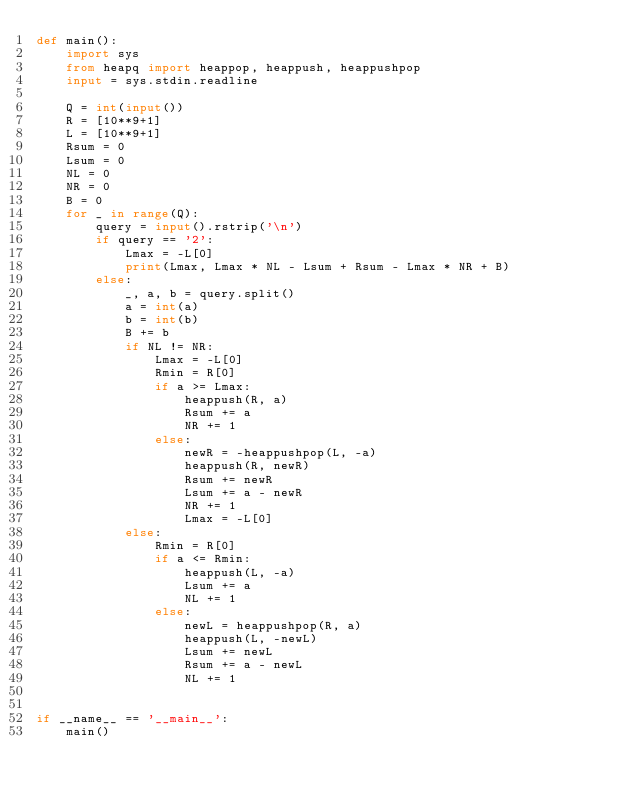<code> <loc_0><loc_0><loc_500><loc_500><_Python_>def main():
    import sys
    from heapq import heappop, heappush, heappushpop
    input = sys.stdin.readline

    Q = int(input())
    R = [10**9+1]
    L = [10**9+1]
    Rsum = 0
    Lsum = 0
    NL = 0
    NR = 0
    B = 0
    for _ in range(Q):
        query = input().rstrip('\n')
        if query == '2':
            Lmax = -L[0]
            print(Lmax, Lmax * NL - Lsum + Rsum - Lmax * NR + B)
        else:
            _, a, b = query.split()
            a = int(a)
            b = int(b)
            B += b
            if NL != NR:
                Lmax = -L[0]
                Rmin = R[0]
                if a >= Lmax:
                    heappush(R, a)
                    Rsum += a
                    NR += 1
                else:
                    newR = -heappushpop(L, -a)
                    heappush(R, newR)
                    Rsum += newR
                    Lsum += a - newR
                    NR += 1
                    Lmax = -L[0]
            else:
                Rmin = R[0]
                if a <= Rmin:
                    heappush(L, -a)
                    Lsum += a
                    NL += 1
                else:
                    newL = heappushpop(R, a)
                    heappush(L, -newL)
                    Lsum += newL
                    Rsum += a - newL
                    NL += 1


if __name__ == '__main__':
    main()
</code> 